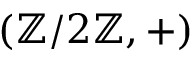<formula> <loc_0><loc_0><loc_500><loc_500>( \mathbb { Z } / 2 \mathbb { Z } , + )</formula> 